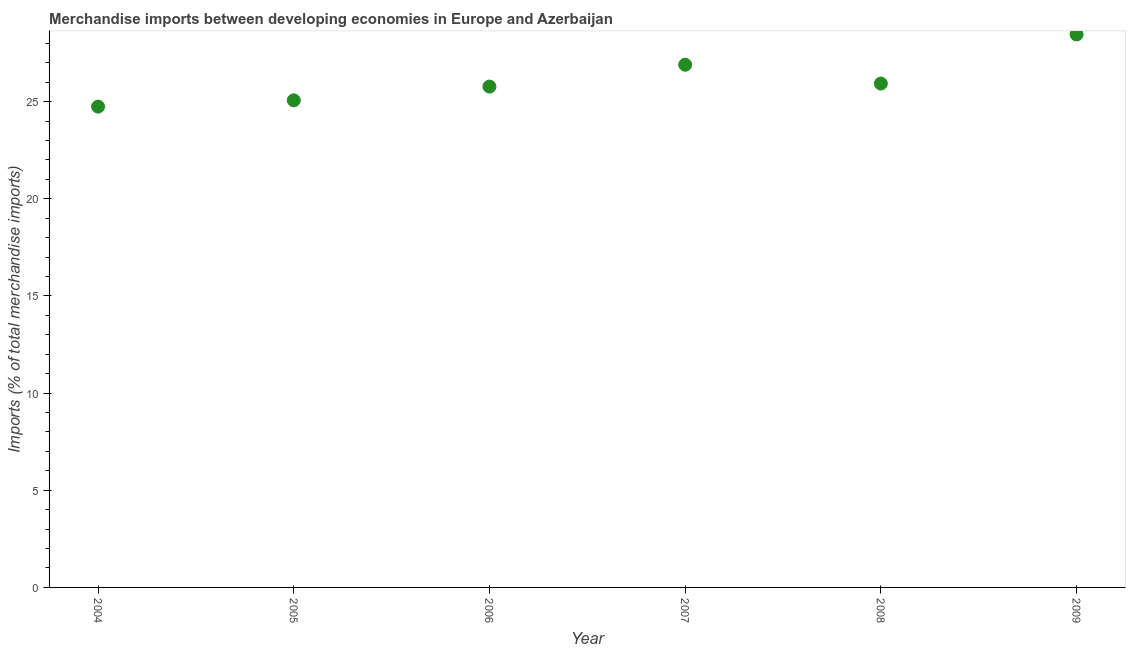What is the merchandise imports in 2006?
Your answer should be compact. 25.77. Across all years, what is the maximum merchandise imports?
Ensure brevity in your answer.  28.46. Across all years, what is the minimum merchandise imports?
Offer a terse response. 24.74. What is the sum of the merchandise imports?
Provide a short and direct response. 156.87. What is the difference between the merchandise imports in 2005 and 2006?
Your answer should be compact. -0.71. What is the average merchandise imports per year?
Your answer should be very brief. 26.15. What is the median merchandise imports?
Your answer should be very brief. 25.85. In how many years, is the merchandise imports greater than 25 %?
Provide a succinct answer. 5. Do a majority of the years between 2009 and 2006 (inclusive) have merchandise imports greater than 4 %?
Your answer should be very brief. Yes. What is the ratio of the merchandise imports in 2007 to that in 2008?
Make the answer very short. 1.04. Is the difference between the merchandise imports in 2005 and 2009 greater than the difference between any two years?
Your response must be concise. No. What is the difference between the highest and the second highest merchandise imports?
Provide a short and direct response. 1.56. What is the difference between the highest and the lowest merchandise imports?
Your answer should be very brief. 3.71. In how many years, is the merchandise imports greater than the average merchandise imports taken over all years?
Make the answer very short. 2. How many dotlines are there?
Offer a terse response. 1. How many years are there in the graph?
Make the answer very short. 6. Does the graph contain any zero values?
Your answer should be very brief. No. Does the graph contain grids?
Offer a very short reply. No. What is the title of the graph?
Provide a succinct answer. Merchandise imports between developing economies in Europe and Azerbaijan. What is the label or title of the Y-axis?
Your answer should be very brief. Imports (% of total merchandise imports). What is the Imports (% of total merchandise imports) in 2004?
Make the answer very short. 24.74. What is the Imports (% of total merchandise imports) in 2005?
Make the answer very short. 25.07. What is the Imports (% of total merchandise imports) in 2006?
Provide a succinct answer. 25.77. What is the Imports (% of total merchandise imports) in 2007?
Your response must be concise. 26.9. What is the Imports (% of total merchandise imports) in 2008?
Offer a terse response. 25.93. What is the Imports (% of total merchandise imports) in 2009?
Your answer should be compact. 28.46. What is the difference between the Imports (% of total merchandise imports) in 2004 and 2005?
Ensure brevity in your answer.  -0.32. What is the difference between the Imports (% of total merchandise imports) in 2004 and 2006?
Provide a short and direct response. -1.03. What is the difference between the Imports (% of total merchandise imports) in 2004 and 2007?
Your answer should be compact. -2.16. What is the difference between the Imports (% of total merchandise imports) in 2004 and 2008?
Provide a short and direct response. -1.19. What is the difference between the Imports (% of total merchandise imports) in 2004 and 2009?
Give a very brief answer. -3.71. What is the difference between the Imports (% of total merchandise imports) in 2005 and 2006?
Keep it short and to the point. -0.71. What is the difference between the Imports (% of total merchandise imports) in 2005 and 2007?
Your answer should be very brief. -1.83. What is the difference between the Imports (% of total merchandise imports) in 2005 and 2008?
Your answer should be very brief. -0.86. What is the difference between the Imports (% of total merchandise imports) in 2005 and 2009?
Provide a short and direct response. -3.39. What is the difference between the Imports (% of total merchandise imports) in 2006 and 2007?
Provide a short and direct response. -1.12. What is the difference between the Imports (% of total merchandise imports) in 2006 and 2008?
Keep it short and to the point. -0.16. What is the difference between the Imports (% of total merchandise imports) in 2006 and 2009?
Ensure brevity in your answer.  -2.68. What is the difference between the Imports (% of total merchandise imports) in 2007 and 2008?
Your answer should be very brief. 0.97. What is the difference between the Imports (% of total merchandise imports) in 2007 and 2009?
Provide a succinct answer. -1.56. What is the difference between the Imports (% of total merchandise imports) in 2008 and 2009?
Your answer should be very brief. -2.53. What is the ratio of the Imports (% of total merchandise imports) in 2004 to that in 2007?
Provide a succinct answer. 0.92. What is the ratio of the Imports (% of total merchandise imports) in 2004 to that in 2008?
Offer a terse response. 0.95. What is the ratio of the Imports (% of total merchandise imports) in 2004 to that in 2009?
Your answer should be compact. 0.87. What is the ratio of the Imports (% of total merchandise imports) in 2005 to that in 2006?
Provide a succinct answer. 0.97. What is the ratio of the Imports (% of total merchandise imports) in 2005 to that in 2007?
Make the answer very short. 0.93. What is the ratio of the Imports (% of total merchandise imports) in 2005 to that in 2008?
Your answer should be compact. 0.97. What is the ratio of the Imports (% of total merchandise imports) in 2005 to that in 2009?
Keep it short and to the point. 0.88. What is the ratio of the Imports (% of total merchandise imports) in 2006 to that in 2007?
Provide a succinct answer. 0.96. What is the ratio of the Imports (% of total merchandise imports) in 2006 to that in 2008?
Give a very brief answer. 0.99. What is the ratio of the Imports (% of total merchandise imports) in 2006 to that in 2009?
Provide a succinct answer. 0.91. What is the ratio of the Imports (% of total merchandise imports) in 2007 to that in 2008?
Keep it short and to the point. 1.04. What is the ratio of the Imports (% of total merchandise imports) in 2007 to that in 2009?
Your answer should be very brief. 0.94. What is the ratio of the Imports (% of total merchandise imports) in 2008 to that in 2009?
Provide a succinct answer. 0.91. 